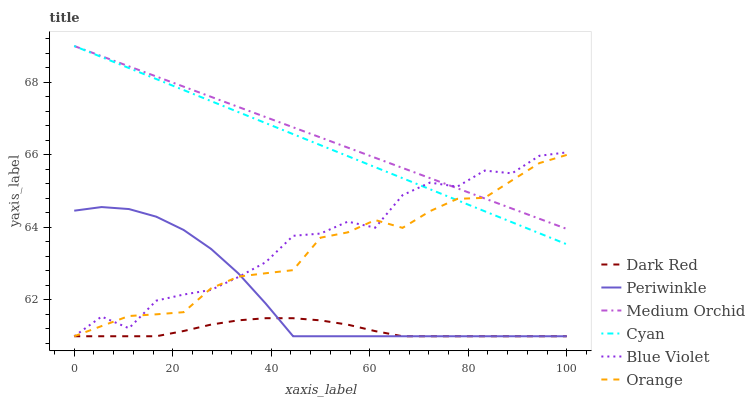Does Periwinkle have the minimum area under the curve?
Answer yes or no. No. Does Periwinkle have the maximum area under the curve?
Answer yes or no. No. Is Periwinkle the smoothest?
Answer yes or no. No. Is Periwinkle the roughest?
Answer yes or no. No. Does Medium Orchid have the lowest value?
Answer yes or no. No. Does Periwinkle have the highest value?
Answer yes or no. No. Is Dark Red less than Cyan?
Answer yes or no. Yes. Is Medium Orchid greater than Periwinkle?
Answer yes or no. Yes. Does Dark Red intersect Cyan?
Answer yes or no. No. 